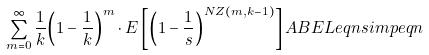<formula> <loc_0><loc_0><loc_500><loc_500>\sum _ { m = 0 } ^ { \infty } \frac { 1 } { k } { \left ( 1 - \frac { 1 } { k } \right ) } ^ { m } \cdot E \left [ { \left ( 1 - \frac { 1 } { s } \right ) } ^ { N Z ( m , k - 1 ) } \right ] \L A B E L { e q n } { s i m p e q n }</formula> 